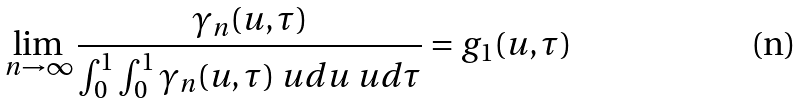Convert formula to latex. <formula><loc_0><loc_0><loc_500><loc_500>\lim _ { n \to \infty } \frac { \gamma _ { n } ( u , \tau ) } { \int _ { 0 } ^ { 1 } \int _ { 0 } ^ { 1 } \gamma _ { n } ( u , \tau ) \ u d u \ u d \tau } = g _ { 1 } ( u , \tau )</formula> 